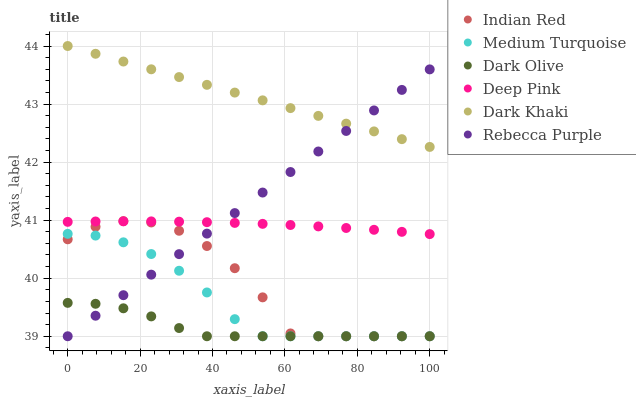Does Dark Olive have the minimum area under the curve?
Answer yes or no. Yes. Does Dark Khaki have the maximum area under the curve?
Answer yes or no. Yes. Does Indian Red have the minimum area under the curve?
Answer yes or no. No. Does Indian Red have the maximum area under the curve?
Answer yes or no. No. Is Dark Khaki the smoothest?
Answer yes or no. Yes. Is Indian Red the roughest?
Answer yes or no. Yes. Is Dark Olive the smoothest?
Answer yes or no. No. Is Dark Olive the roughest?
Answer yes or no. No. Does Indian Red have the lowest value?
Answer yes or no. Yes. Does Dark Khaki have the lowest value?
Answer yes or no. No. Does Dark Khaki have the highest value?
Answer yes or no. Yes. Does Indian Red have the highest value?
Answer yes or no. No. Is Dark Olive less than Dark Khaki?
Answer yes or no. Yes. Is Deep Pink greater than Dark Olive?
Answer yes or no. Yes. Does Medium Turquoise intersect Dark Olive?
Answer yes or no. Yes. Is Medium Turquoise less than Dark Olive?
Answer yes or no. No. Is Medium Turquoise greater than Dark Olive?
Answer yes or no. No. Does Dark Olive intersect Dark Khaki?
Answer yes or no. No. 